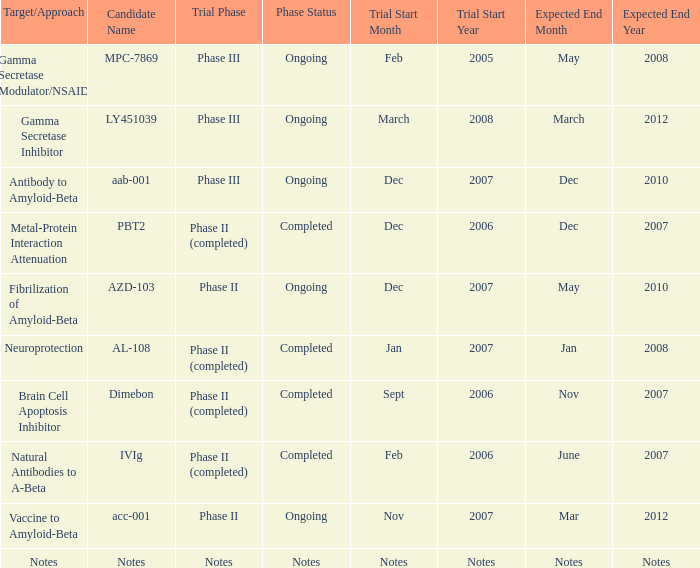What is the trial period, when the estimated conclusion date is june 2007? Phase II (completed). 